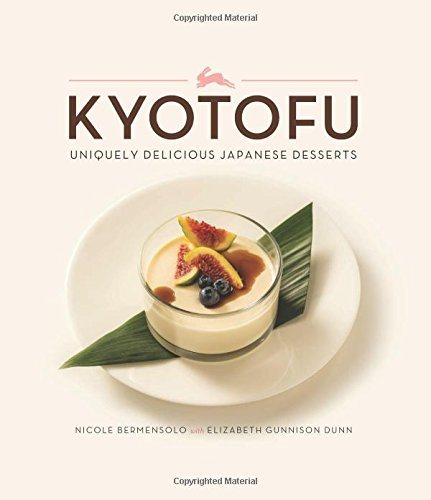Is this book related to Cookbooks, Food & Wine? Yes, this book is indeed related to Cookbooks, Food & Wine, offering readers an exquisite insight into the art of Japanese desserts. 